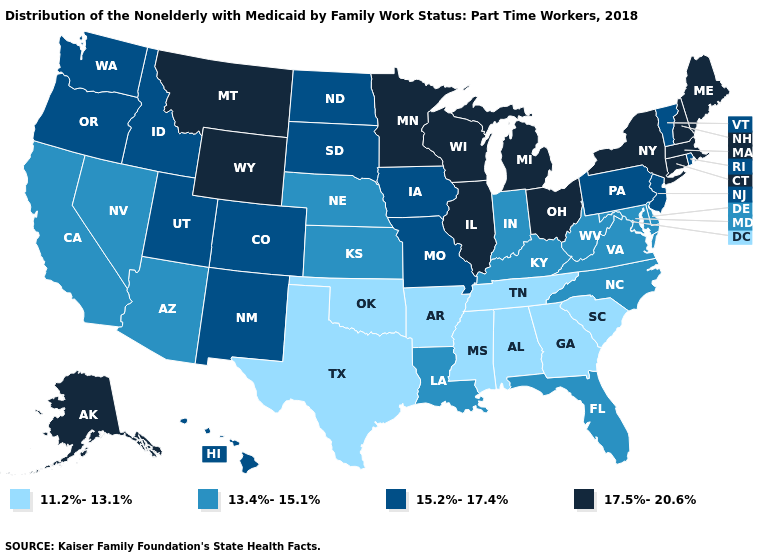Name the states that have a value in the range 13.4%-15.1%?
Give a very brief answer. Arizona, California, Delaware, Florida, Indiana, Kansas, Kentucky, Louisiana, Maryland, Nebraska, Nevada, North Carolina, Virginia, West Virginia. Among the states that border Nebraska , which have the lowest value?
Write a very short answer. Kansas. Does New Hampshire have the lowest value in the Northeast?
Answer briefly. No. Name the states that have a value in the range 17.5%-20.6%?
Keep it brief. Alaska, Connecticut, Illinois, Maine, Massachusetts, Michigan, Minnesota, Montana, New Hampshire, New York, Ohio, Wisconsin, Wyoming. Does Texas have the lowest value in the USA?
Be succinct. Yes. Name the states that have a value in the range 17.5%-20.6%?
Short answer required. Alaska, Connecticut, Illinois, Maine, Massachusetts, Michigan, Minnesota, Montana, New Hampshire, New York, Ohio, Wisconsin, Wyoming. Does Iowa have the lowest value in the USA?
Short answer required. No. What is the lowest value in the Northeast?
Quick response, please. 15.2%-17.4%. Does Connecticut have the lowest value in the USA?
Write a very short answer. No. Name the states that have a value in the range 17.5%-20.6%?
Write a very short answer. Alaska, Connecticut, Illinois, Maine, Massachusetts, Michigan, Minnesota, Montana, New Hampshire, New York, Ohio, Wisconsin, Wyoming. Does North Dakota have a higher value than Connecticut?
Keep it brief. No. What is the highest value in the Northeast ?
Short answer required. 17.5%-20.6%. Name the states that have a value in the range 17.5%-20.6%?
Write a very short answer. Alaska, Connecticut, Illinois, Maine, Massachusetts, Michigan, Minnesota, Montana, New Hampshire, New York, Ohio, Wisconsin, Wyoming. What is the value of Nevada?
Quick response, please. 13.4%-15.1%. Name the states that have a value in the range 11.2%-13.1%?
Be succinct. Alabama, Arkansas, Georgia, Mississippi, Oklahoma, South Carolina, Tennessee, Texas. 